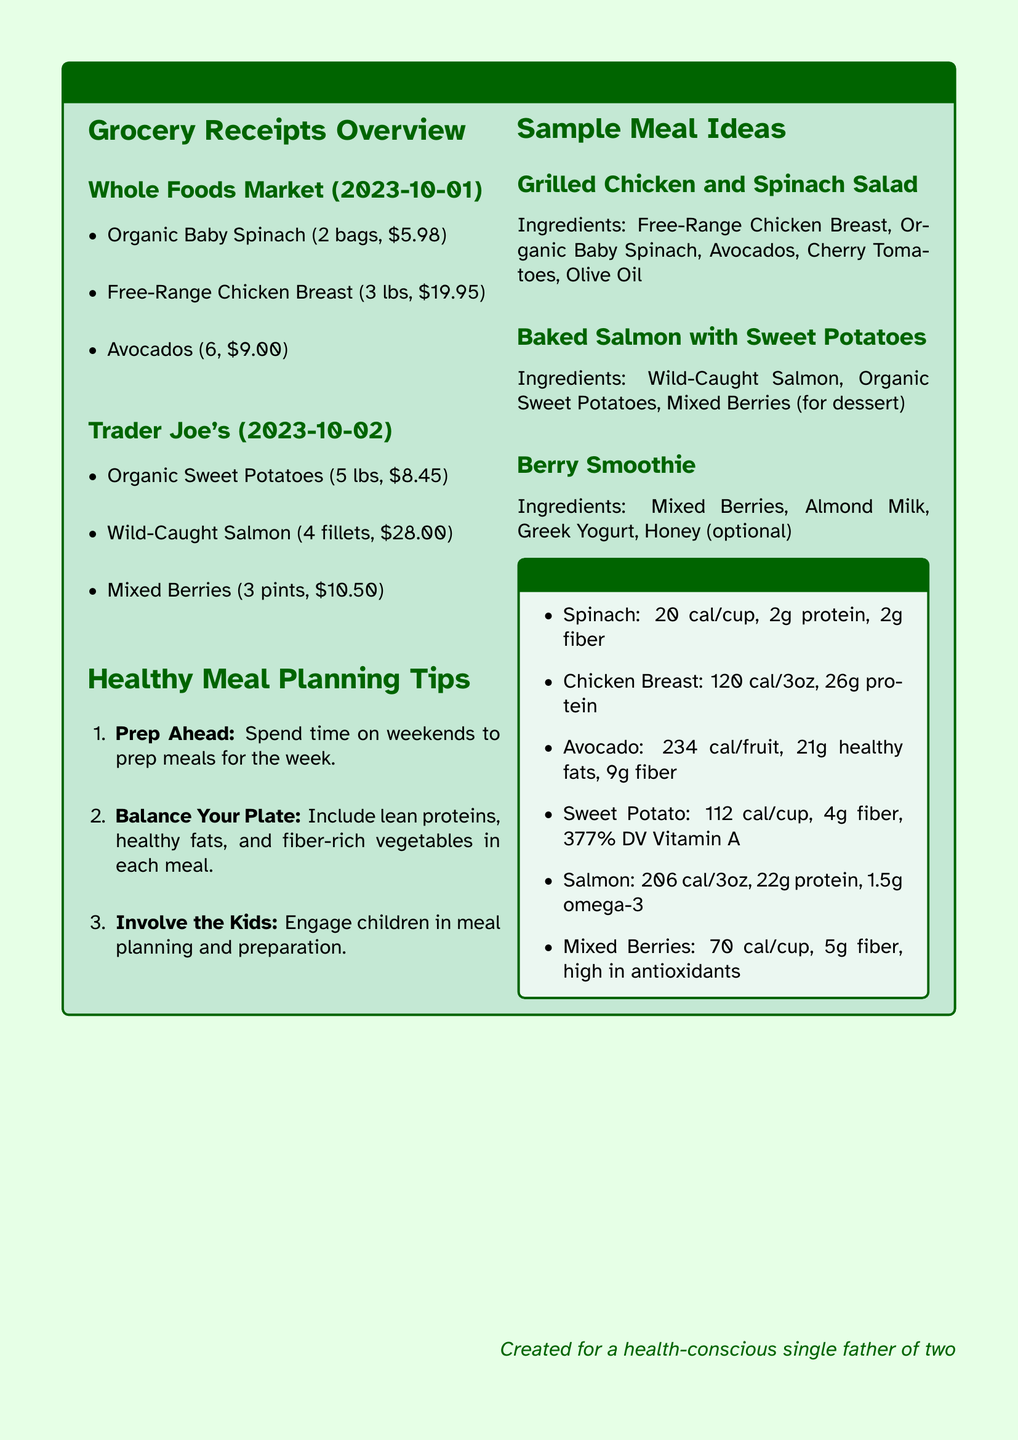What is the date of the Whole Foods Market receipt? The receipt date shown in the document is listed under Whole Foods Market.
Answer: 2023-10-01 How much did the Free-Range Chicken Breast cost? The cost of Free-Range Chicken Breast is specified in the items under Whole Foods Market.
Answer: $19.95 What are the ingredients for the Baked Salmon with Sweet Potatoes? The ingredients are listed under the sample meal ideas section.
Answer: Wild-Caught Salmon, Organic Sweet Potatoes, Mixed Berries How many pints of Mixed Berries were purchased? The document lists the number of Mixed Berries purchased under Trader Joe's.
Answer: 3 pints What is the caloric content of Sweet Potato per cup? The nutritional highlights provide caloric content for Sweet Potato.
Answer: 112 cal/cup How many grams of protein does a 3 oz serving of Chicken Breast provide? The nutritional highlights state the protein value for Chicken Breast per 3 oz.
Answer: 26g protein What is one tip for meal planning mentioned in the document? The meal planning tips section includes several suggestions for healthy cooking.
Answer: Prep Ahead How many avocados were purchased? The total number of avocados can be found in the Whole Foods Market list.
Answer: 6 What is the caloric content of Spinach per cup? The document specifies the caloric content for Spinach in the nutritional highlights.
Answer: 20 cal/cup 